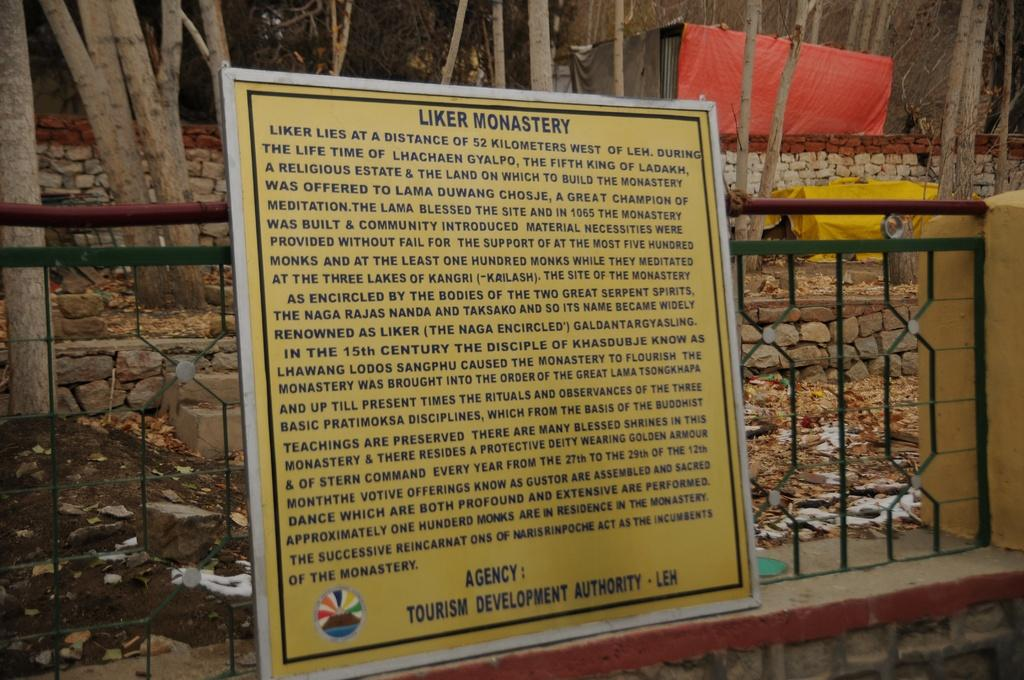What is the main object in the image? There is a board in the image. What other object can be seen in the image? There is a grille in the image. What can be seen in the background of the image? There are branches, clothes, and walls in the background of the image. What type of drum can be heard playing in the background of the image? There is no drum present in the image, nor is there any sound associated with it. 